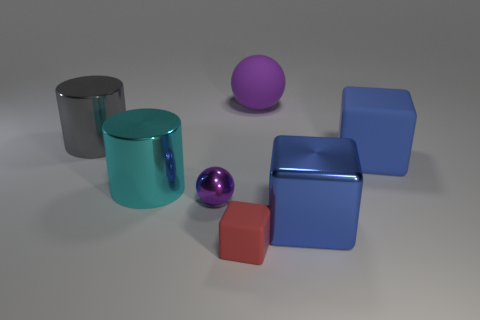How many large rubber blocks are the same color as the tiny rubber cube?
Keep it short and to the point. 0. How big is the blue shiny cube?
Make the answer very short. Large. Is the metal ball the same size as the cyan cylinder?
Ensure brevity in your answer.  No. What is the color of the large object that is left of the big metal block and right of the tiny purple metallic sphere?
Provide a short and direct response. Purple. What number of other large things have the same material as the big purple thing?
Your response must be concise. 1. How many big cyan rubber balls are there?
Your response must be concise. 0. There is a shiny sphere; does it have the same size as the cube behind the purple metallic ball?
Offer a very short reply. No. What material is the small object right of the small thing that is to the left of the small block made of?
Offer a terse response. Rubber. There is a purple thing behind the large blue block behind the big shiny thing that is on the right side of the purple metallic object; how big is it?
Provide a succinct answer. Large. Do the red thing and the big thing that is in front of the cyan metallic object have the same shape?
Your answer should be compact. Yes. 